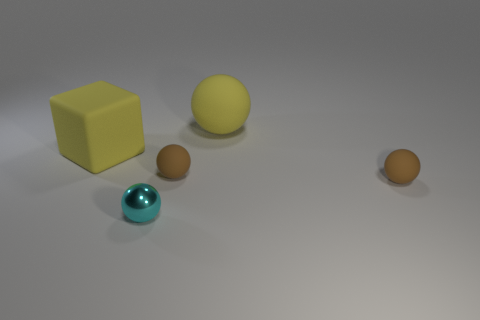There is a matte sphere in front of the tiny rubber ball that is left of the large yellow matte object that is behind the yellow rubber block; what is its size?
Make the answer very short. Small. There is a small cyan metallic sphere; what number of big rubber cubes are left of it?
Make the answer very short. 1. Is the number of tiny green rubber cubes greater than the number of cyan metallic objects?
Make the answer very short. No. What is the size of the matte sphere that is the same color as the large rubber cube?
Provide a short and direct response. Large. There is a ball that is behind the small shiny ball and to the left of the yellow sphere; how big is it?
Provide a short and direct response. Small. What material is the small brown sphere in front of the tiny brown matte object that is left of the brown matte ball that is to the right of the yellow rubber sphere?
Ensure brevity in your answer.  Rubber. There is a big thing that is the same color as the large matte block; what material is it?
Keep it short and to the point. Rubber. There is a large rubber thing to the right of the tiny shiny sphere; is it the same color as the small ball right of the big yellow matte ball?
Give a very brief answer. No. The brown matte object to the right of the big yellow matte thing that is right of the big yellow matte object to the left of the metallic object is what shape?
Make the answer very short. Sphere. There is a rubber object that is on the left side of the yellow rubber ball and in front of the cube; what shape is it?
Give a very brief answer. Sphere. 